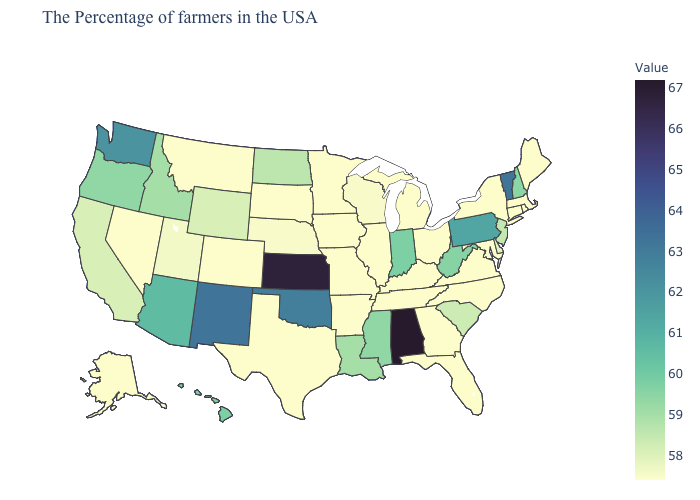Does Louisiana have the lowest value in the South?
Answer briefly. No. Does Vermont have the highest value in the Northeast?
Concise answer only. Yes. Which states have the lowest value in the USA?
Concise answer only. Maine, Massachusetts, Rhode Island, Connecticut, New York, Maryland, Virginia, North Carolina, Ohio, Florida, Georgia, Michigan, Kentucky, Tennessee, Illinois, Missouri, Arkansas, Minnesota, Iowa, Texas, South Dakota, Colorado, Montana, Nevada, Alaska. Among the states that border Massachusetts , does New York have the lowest value?
Give a very brief answer. Yes. Which states hav the highest value in the Northeast?
Give a very brief answer. Vermont. Is the legend a continuous bar?
Be succinct. Yes. 